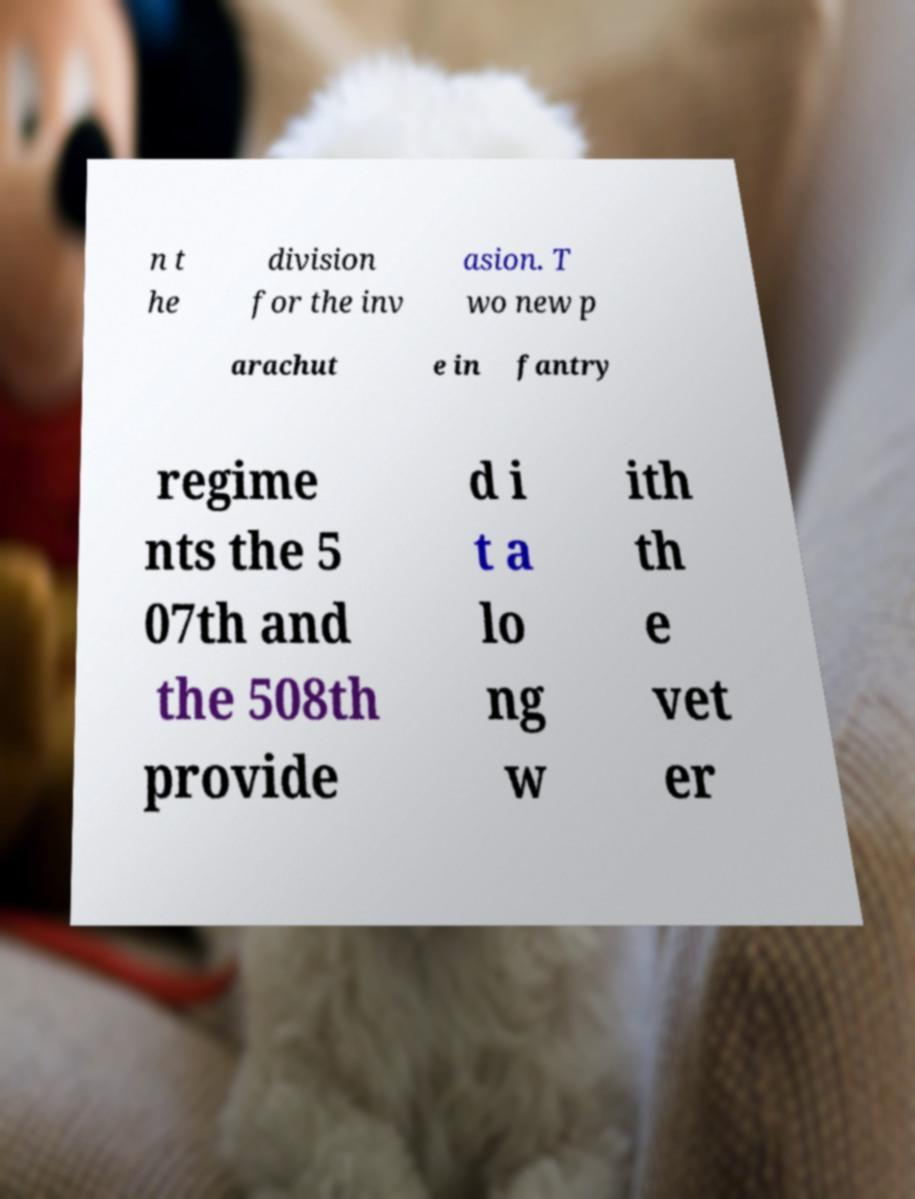Could you assist in decoding the text presented in this image and type it out clearly? n t he division for the inv asion. T wo new p arachut e in fantry regime nts the 5 07th and the 508th provide d i t a lo ng w ith th e vet er 